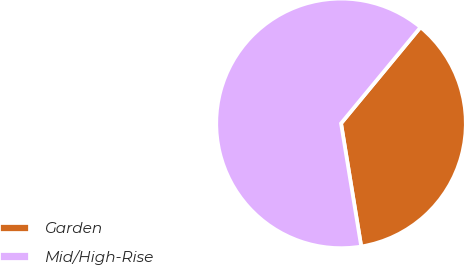Convert chart. <chart><loc_0><loc_0><loc_500><loc_500><pie_chart><fcel>Garden<fcel>Mid/High-Rise<nl><fcel>36.42%<fcel>63.58%<nl></chart> 